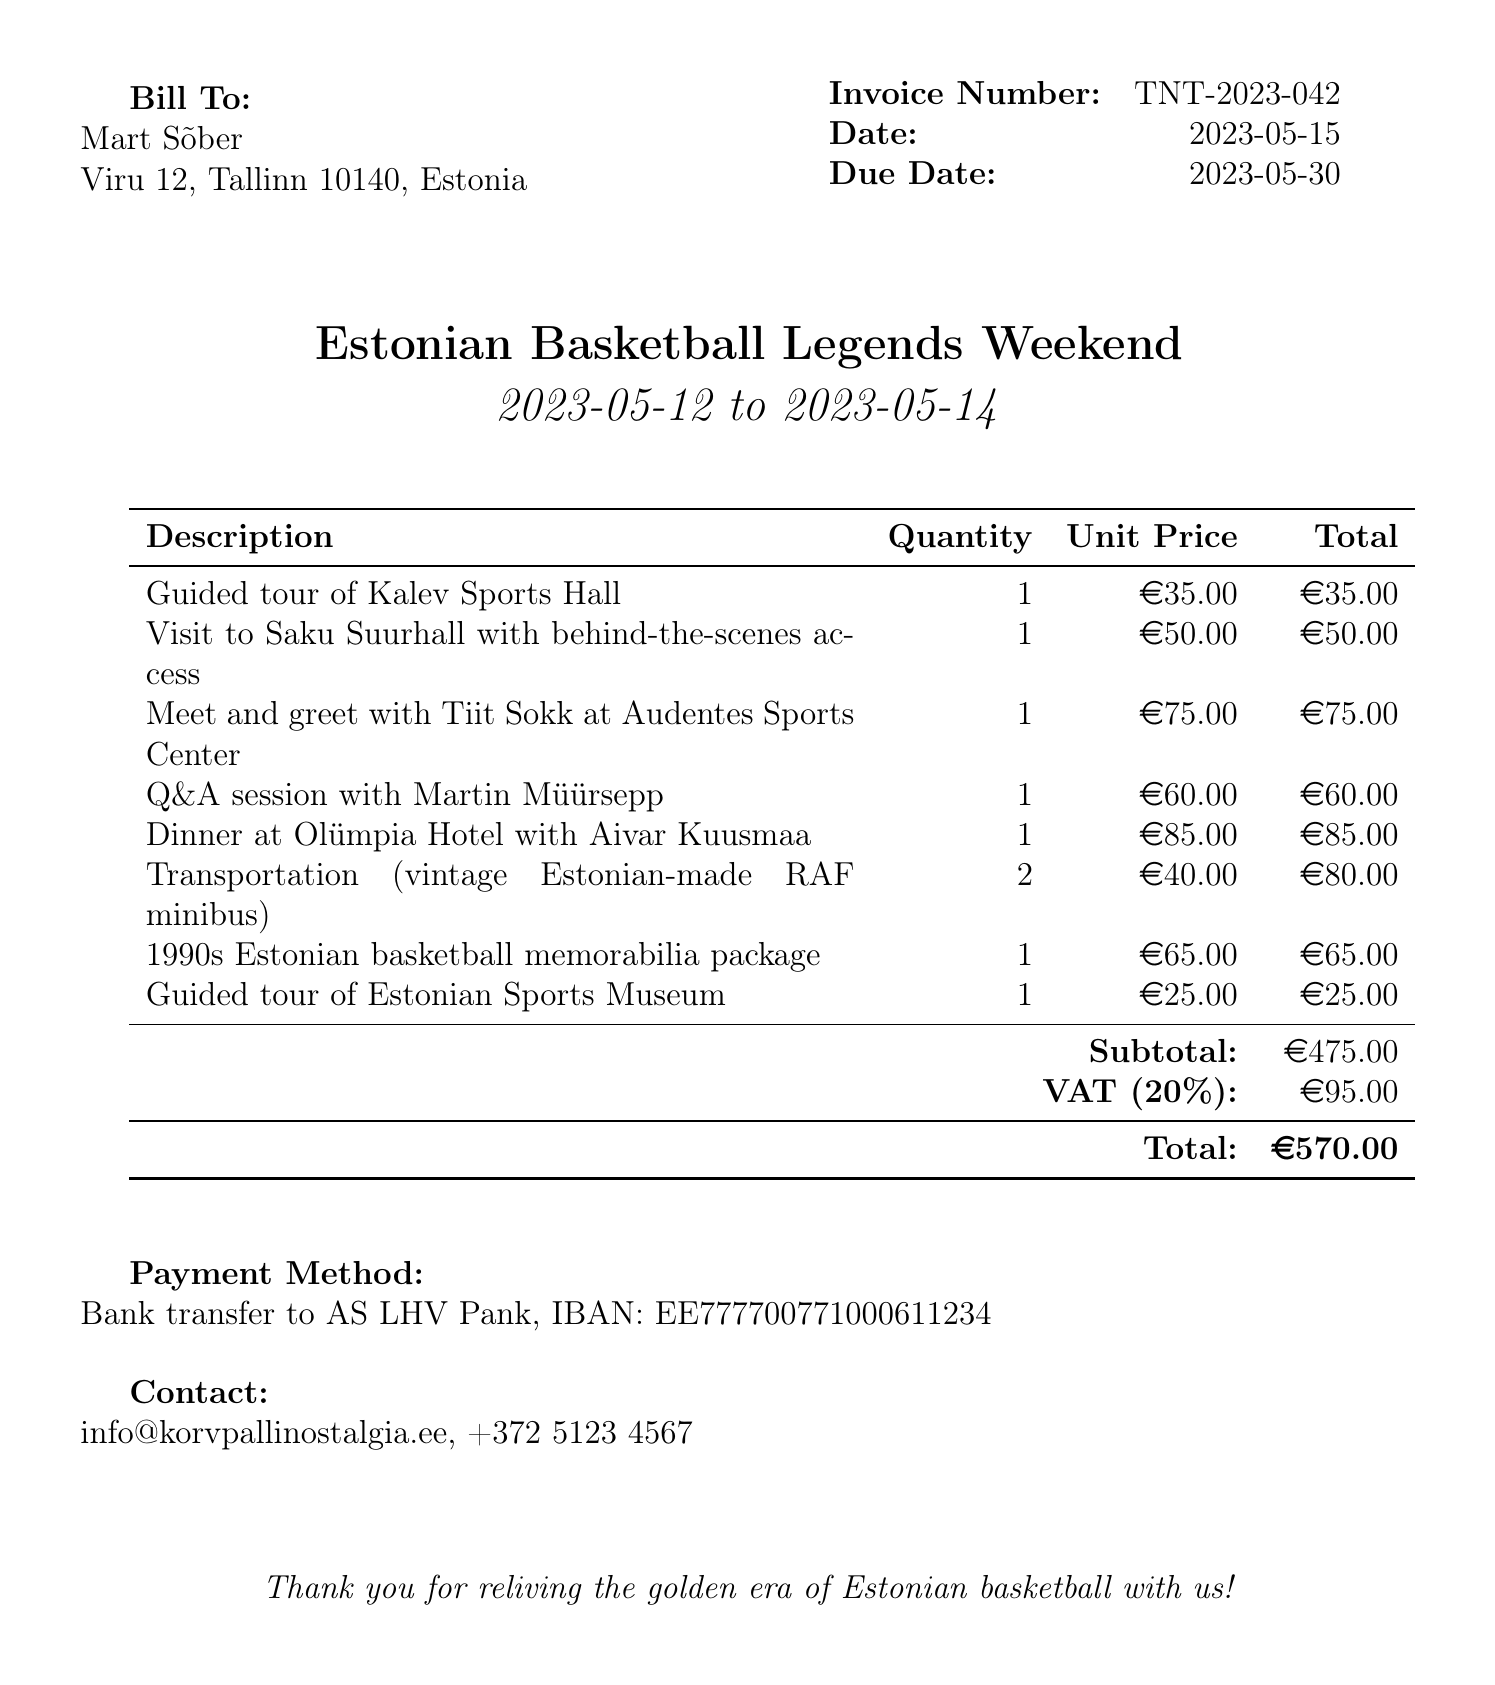what is the invoice number? The invoice number is clearly stated in the document under the invoice details section.
Answer: TNT-2023-042 who is the client? The client's name is mentioned in the bill to section of the document.
Answer: Mart Sõber what is the tour package title? The title of the tour package is presented prominently in the document.
Answer: Estonian Basketball Legends Weekend what is the total amount due? The total amount due is calculated at the end of the invoice, including subtotal and VAT.
Answer: €570.00 how many items are listed in the invoice? Counting from the items section, we can find the number of unique entries listed.
Answer: 8 what is the VAT rate applied to the invoice? The VAT rate specified in the document shows the applicable tax rate for the services.
Answer: 20% who is the tour organizer? The name of the tour organizer is found near the bottom of the invoice.
Answer: Korvpalli Nostalgia OÜ when is the due date for payment? The due date is clearly indicated in the invoice details section.
Answer: 2023-05-30 what payment method is specified in the document? The payment method is presented in a specific section of the invoice detailing how to settle the amount.
Answer: Bank transfer to AS LHV Pank, IBAN: EE777700771000611234 